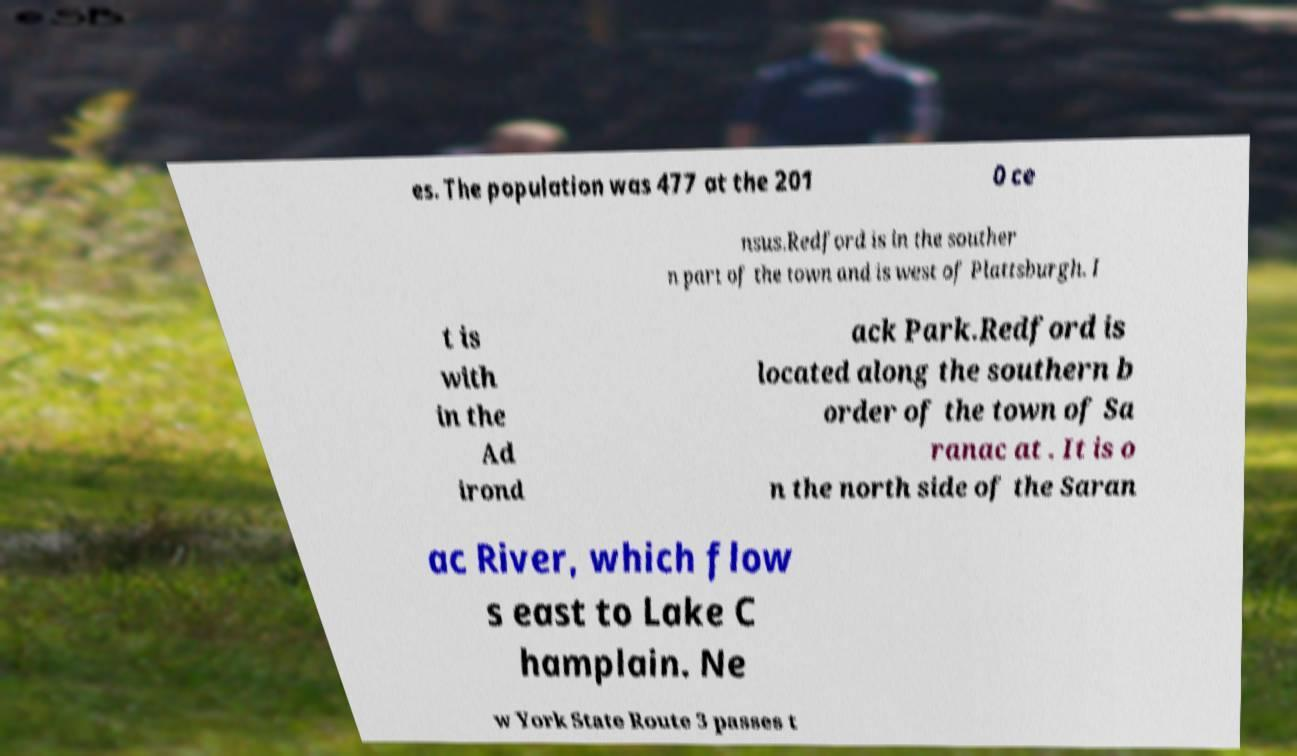For documentation purposes, I need the text within this image transcribed. Could you provide that? es. The population was 477 at the 201 0 ce nsus.Redford is in the souther n part of the town and is west of Plattsburgh. I t is with in the Ad irond ack Park.Redford is located along the southern b order of the town of Sa ranac at . It is o n the north side of the Saran ac River, which flow s east to Lake C hamplain. Ne w York State Route 3 passes t 